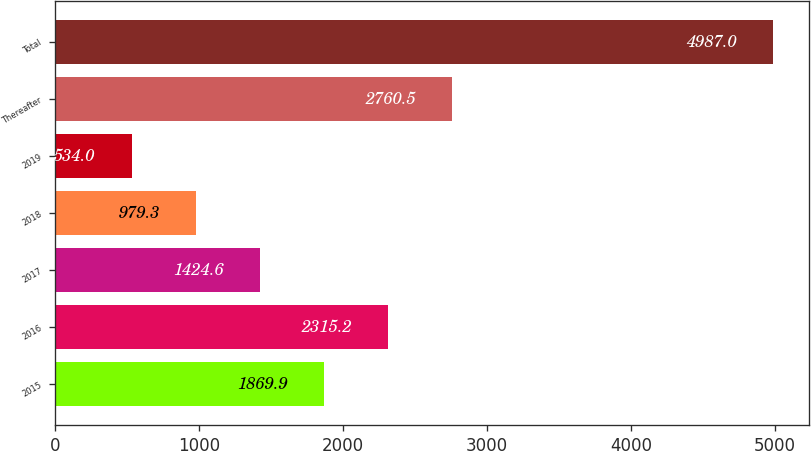Convert chart. <chart><loc_0><loc_0><loc_500><loc_500><bar_chart><fcel>2015<fcel>2016<fcel>2017<fcel>2018<fcel>2019<fcel>Thereafter<fcel>Total<nl><fcel>1869.9<fcel>2315.2<fcel>1424.6<fcel>979.3<fcel>534<fcel>2760.5<fcel>4987<nl></chart> 